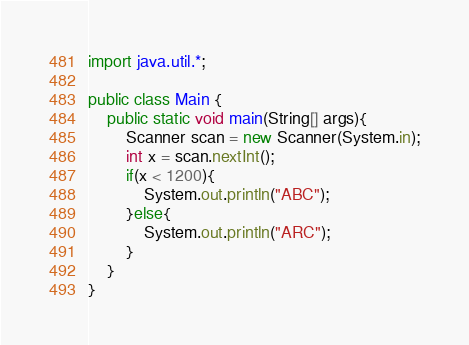<code> <loc_0><loc_0><loc_500><loc_500><_Java_>import java.util.*;

public class Main {
    public static void main(String[] args){
        Scanner scan = new Scanner(System.in);
        int x = scan.nextInt();
        if(x < 1200){
            System.out.println("ABC");
        }else{
            System.out.println("ARC");
        }
    }
}</code> 